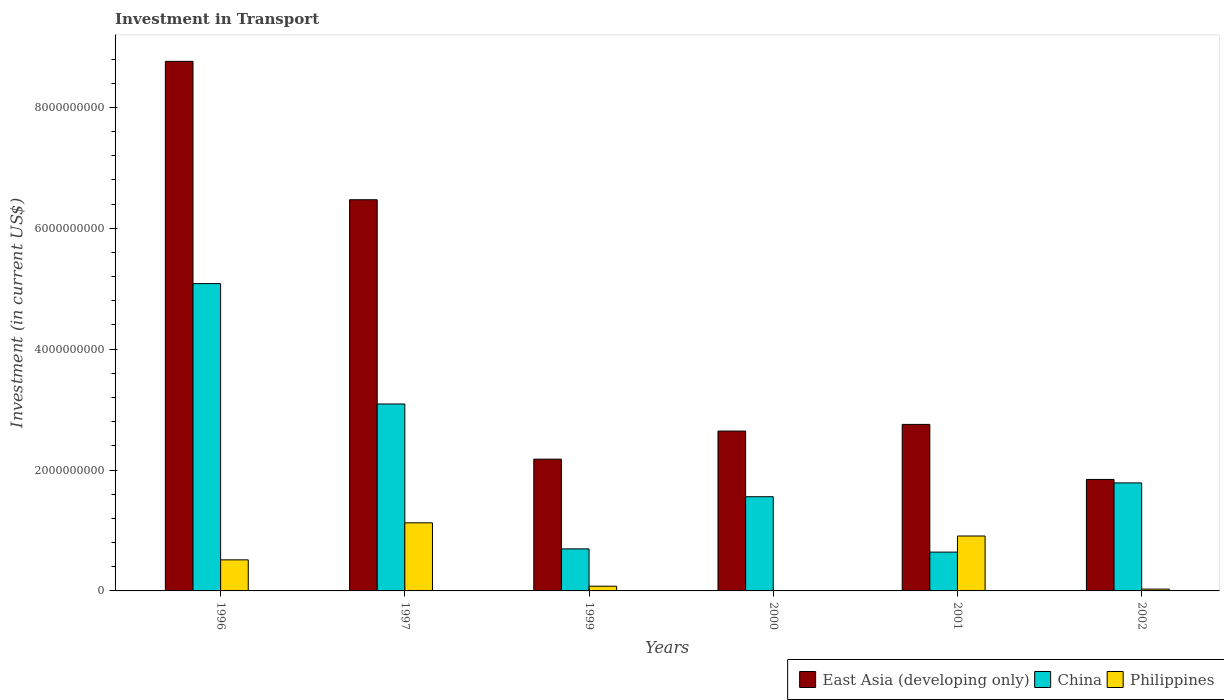Are the number of bars on each tick of the X-axis equal?
Offer a very short reply. Yes. How many bars are there on the 5th tick from the right?
Your answer should be very brief. 3. In how many cases, is the number of bars for a given year not equal to the number of legend labels?
Your answer should be very brief. 0. What is the amount invested in transport in Philippines in 2002?
Provide a short and direct response. 3.01e+07. Across all years, what is the maximum amount invested in transport in Philippines?
Keep it short and to the point. 1.13e+09. Across all years, what is the minimum amount invested in transport in China?
Provide a succinct answer. 6.42e+08. What is the total amount invested in transport in East Asia (developing only) in the graph?
Ensure brevity in your answer.  2.47e+1. What is the difference between the amount invested in transport in China in 1996 and that in 1997?
Ensure brevity in your answer.  1.99e+09. What is the difference between the amount invested in transport in Philippines in 1997 and the amount invested in transport in East Asia (developing only) in 2001?
Your answer should be compact. -1.63e+09. What is the average amount invested in transport in China per year?
Keep it short and to the point. 2.14e+09. In the year 1996, what is the difference between the amount invested in transport in China and amount invested in transport in Philippines?
Your response must be concise. 4.57e+09. What is the ratio of the amount invested in transport in Philippines in 1996 to that in 1997?
Provide a short and direct response. 0.46. Is the amount invested in transport in China in 1996 less than that in 1999?
Your answer should be compact. No. Is the difference between the amount invested in transport in China in 1997 and 2001 greater than the difference between the amount invested in transport in Philippines in 1997 and 2001?
Your answer should be compact. Yes. What is the difference between the highest and the second highest amount invested in transport in China?
Make the answer very short. 1.99e+09. What is the difference between the highest and the lowest amount invested in transport in China?
Your answer should be very brief. 4.44e+09. Is the sum of the amount invested in transport in China in 1996 and 2001 greater than the maximum amount invested in transport in Philippines across all years?
Offer a terse response. Yes. What does the 1st bar from the left in 2001 represents?
Your answer should be very brief. East Asia (developing only). Is it the case that in every year, the sum of the amount invested in transport in Philippines and amount invested in transport in China is greater than the amount invested in transport in East Asia (developing only)?
Ensure brevity in your answer.  No. How many years are there in the graph?
Keep it short and to the point. 6. What is the difference between two consecutive major ticks on the Y-axis?
Ensure brevity in your answer.  2.00e+09. How are the legend labels stacked?
Ensure brevity in your answer.  Horizontal. What is the title of the graph?
Your answer should be very brief. Investment in Transport. What is the label or title of the X-axis?
Offer a very short reply. Years. What is the label or title of the Y-axis?
Your answer should be very brief. Investment (in current US$). What is the Investment (in current US$) in East Asia (developing only) in 1996?
Your answer should be very brief. 8.76e+09. What is the Investment (in current US$) in China in 1996?
Keep it short and to the point. 5.08e+09. What is the Investment (in current US$) in Philippines in 1996?
Ensure brevity in your answer.  5.14e+08. What is the Investment (in current US$) of East Asia (developing only) in 1997?
Give a very brief answer. 6.47e+09. What is the Investment (in current US$) of China in 1997?
Provide a succinct answer. 3.09e+09. What is the Investment (in current US$) in Philippines in 1997?
Provide a succinct answer. 1.13e+09. What is the Investment (in current US$) in East Asia (developing only) in 1999?
Your answer should be compact. 2.18e+09. What is the Investment (in current US$) of China in 1999?
Your response must be concise. 6.96e+08. What is the Investment (in current US$) of Philippines in 1999?
Your response must be concise. 7.83e+07. What is the Investment (in current US$) of East Asia (developing only) in 2000?
Provide a succinct answer. 2.64e+09. What is the Investment (in current US$) of China in 2000?
Make the answer very short. 1.56e+09. What is the Investment (in current US$) in Philippines in 2000?
Offer a very short reply. 4.90e+06. What is the Investment (in current US$) of East Asia (developing only) in 2001?
Offer a terse response. 2.76e+09. What is the Investment (in current US$) of China in 2001?
Ensure brevity in your answer.  6.42e+08. What is the Investment (in current US$) of Philippines in 2001?
Keep it short and to the point. 9.08e+08. What is the Investment (in current US$) of East Asia (developing only) in 2002?
Your answer should be compact. 1.84e+09. What is the Investment (in current US$) of China in 2002?
Make the answer very short. 1.79e+09. What is the Investment (in current US$) in Philippines in 2002?
Keep it short and to the point. 3.01e+07. Across all years, what is the maximum Investment (in current US$) in East Asia (developing only)?
Keep it short and to the point. 8.76e+09. Across all years, what is the maximum Investment (in current US$) of China?
Your response must be concise. 5.08e+09. Across all years, what is the maximum Investment (in current US$) of Philippines?
Your answer should be compact. 1.13e+09. Across all years, what is the minimum Investment (in current US$) in East Asia (developing only)?
Your response must be concise. 1.84e+09. Across all years, what is the minimum Investment (in current US$) in China?
Provide a short and direct response. 6.42e+08. Across all years, what is the minimum Investment (in current US$) in Philippines?
Keep it short and to the point. 4.90e+06. What is the total Investment (in current US$) in East Asia (developing only) in the graph?
Your answer should be compact. 2.47e+1. What is the total Investment (in current US$) of China in the graph?
Offer a very short reply. 1.29e+1. What is the total Investment (in current US$) of Philippines in the graph?
Offer a terse response. 2.66e+09. What is the difference between the Investment (in current US$) in East Asia (developing only) in 1996 and that in 1997?
Offer a very short reply. 2.29e+09. What is the difference between the Investment (in current US$) in China in 1996 and that in 1997?
Your response must be concise. 1.99e+09. What is the difference between the Investment (in current US$) in Philippines in 1996 and that in 1997?
Your answer should be compact. -6.13e+08. What is the difference between the Investment (in current US$) of East Asia (developing only) in 1996 and that in 1999?
Your response must be concise. 6.58e+09. What is the difference between the Investment (in current US$) of China in 1996 and that in 1999?
Give a very brief answer. 4.39e+09. What is the difference between the Investment (in current US$) of Philippines in 1996 and that in 1999?
Provide a short and direct response. 4.36e+08. What is the difference between the Investment (in current US$) of East Asia (developing only) in 1996 and that in 2000?
Your answer should be compact. 6.12e+09. What is the difference between the Investment (in current US$) of China in 1996 and that in 2000?
Make the answer very short. 3.53e+09. What is the difference between the Investment (in current US$) in Philippines in 1996 and that in 2000?
Keep it short and to the point. 5.09e+08. What is the difference between the Investment (in current US$) in East Asia (developing only) in 1996 and that in 2001?
Your answer should be very brief. 6.01e+09. What is the difference between the Investment (in current US$) of China in 1996 and that in 2001?
Your response must be concise. 4.44e+09. What is the difference between the Investment (in current US$) of Philippines in 1996 and that in 2001?
Your answer should be very brief. -3.94e+08. What is the difference between the Investment (in current US$) in East Asia (developing only) in 1996 and that in 2002?
Keep it short and to the point. 6.92e+09. What is the difference between the Investment (in current US$) in China in 1996 and that in 2002?
Keep it short and to the point. 3.30e+09. What is the difference between the Investment (in current US$) in Philippines in 1996 and that in 2002?
Offer a terse response. 4.84e+08. What is the difference between the Investment (in current US$) in East Asia (developing only) in 1997 and that in 1999?
Offer a very short reply. 4.29e+09. What is the difference between the Investment (in current US$) in China in 1997 and that in 1999?
Offer a very short reply. 2.40e+09. What is the difference between the Investment (in current US$) in Philippines in 1997 and that in 1999?
Your response must be concise. 1.05e+09. What is the difference between the Investment (in current US$) in East Asia (developing only) in 1997 and that in 2000?
Offer a terse response. 3.83e+09. What is the difference between the Investment (in current US$) of China in 1997 and that in 2000?
Provide a succinct answer. 1.53e+09. What is the difference between the Investment (in current US$) of Philippines in 1997 and that in 2000?
Provide a succinct answer. 1.12e+09. What is the difference between the Investment (in current US$) of East Asia (developing only) in 1997 and that in 2001?
Make the answer very short. 3.72e+09. What is the difference between the Investment (in current US$) in China in 1997 and that in 2001?
Your response must be concise. 2.45e+09. What is the difference between the Investment (in current US$) of Philippines in 1997 and that in 2001?
Your response must be concise. 2.18e+08. What is the difference between the Investment (in current US$) in East Asia (developing only) in 1997 and that in 2002?
Provide a short and direct response. 4.63e+09. What is the difference between the Investment (in current US$) in China in 1997 and that in 2002?
Your answer should be very brief. 1.31e+09. What is the difference between the Investment (in current US$) in Philippines in 1997 and that in 2002?
Make the answer very short. 1.10e+09. What is the difference between the Investment (in current US$) in East Asia (developing only) in 1999 and that in 2000?
Provide a short and direct response. -4.65e+08. What is the difference between the Investment (in current US$) in China in 1999 and that in 2000?
Your answer should be very brief. -8.63e+08. What is the difference between the Investment (in current US$) of Philippines in 1999 and that in 2000?
Your answer should be compact. 7.34e+07. What is the difference between the Investment (in current US$) of East Asia (developing only) in 1999 and that in 2001?
Your answer should be very brief. -5.75e+08. What is the difference between the Investment (in current US$) of China in 1999 and that in 2001?
Make the answer very short. 5.33e+07. What is the difference between the Investment (in current US$) of Philippines in 1999 and that in 2001?
Your answer should be compact. -8.30e+08. What is the difference between the Investment (in current US$) of East Asia (developing only) in 1999 and that in 2002?
Provide a short and direct response. 3.35e+08. What is the difference between the Investment (in current US$) of China in 1999 and that in 2002?
Your answer should be very brief. -1.09e+09. What is the difference between the Investment (in current US$) in Philippines in 1999 and that in 2002?
Offer a terse response. 4.82e+07. What is the difference between the Investment (in current US$) of East Asia (developing only) in 2000 and that in 2001?
Make the answer very short. -1.10e+08. What is the difference between the Investment (in current US$) of China in 2000 and that in 2001?
Keep it short and to the point. 9.16e+08. What is the difference between the Investment (in current US$) in Philippines in 2000 and that in 2001?
Provide a succinct answer. -9.04e+08. What is the difference between the Investment (in current US$) in East Asia (developing only) in 2000 and that in 2002?
Provide a short and direct response. 8.00e+08. What is the difference between the Investment (in current US$) of China in 2000 and that in 2002?
Your response must be concise. -2.29e+08. What is the difference between the Investment (in current US$) of Philippines in 2000 and that in 2002?
Give a very brief answer. -2.52e+07. What is the difference between the Investment (in current US$) in East Asia (developing only) in 2001 and that in 2002?
Provide a succinct answer. 9.11e+08. What is the difference between the Investment (in current US$) of China in 2001 and that in 2002?
Offer a very short reply. -1.14e+09. What is the difference between the Investment (in current US$) of Philippines in 2001 and that in 2002?
Give a very brief answer. 8.78e+08. What is the difference between the Investment (in current US$) of East Asia (developing only) in 1996 and the Investment (in current US$) of China in 1997?
Your answer should be compact. 5.67e+09. What is the difference between the Investment (in current US$) of East Asia (developing only) in 1996 and the Investment (in current US$) of Philippines in 1997?
Your answer should be very brief. 7.63e+09. What is the difference between the Investment (in current US$) in China in 1996 and the Investment (in current US$) in Philippines in 1997?
Your answer should be compact. 3.96e+09. What is the difference between the Investment (in current US$) in East Asia (developing only) in 1996 and the Investment (in current US$) in China in 1999?
Provide a short and direct response. 8.07e+09. What is the difference between the Investment (in current US$) in East Asia (developing only) in 1996 and the Investment (in current US$) in Philippines in 1999?
Ensure brevity in your answer.  8.68e+09. What is the difference between the Investment (in current US$) of China in 1996 and the Investment (in current US$) of Philippines in 1999?
Offer a very short reply. 5.01e+09. What is the difference between the Investment (in current US$) in East Asia (developing only) in 1996 and the Investment (in current US$) in China in 2000?
Provide a short and direct response. 7.20e+09. What is the difference between the Investment (in current US$) of East Asia (developing only) in 1996 and the Investment (in current US$) of Philippines in 2000?
Your answer should be compact. 8.76e+09. What is the difference between the Investment (in current US$) in China in 1996 and the Investment (in current US$) in Philippines in 2000?
Your answer should be compact. 5.08e+09. What is the difference between the Investment (in current US$) of East Asia (developing only) in 1996 and the Investment (in current US$) of China in 2001?
Your answer should be compact. 8.12e+09. What is the difference between the Investment (in current US$) in East Asia (developing only) in 1996 and the Investment (in current US$) in Philippines in 2001?
Your response must be concise. 7.85e+09. What is the difference between the Investment (in current US$) in China in 1996 and the Investment (in current US$) in Philippines in 2001?
Provide a succinct answer. 4.18e+09. What is the difference between the Investment (in current US$) in East Asia (developing only) in 1996 and the Investment (in current US$) in China in 2002?
Offer a terse response. 6.97e+09. What is the difference between the Investment (in current US$) of East Asia (developing only) in 1996 and the Investment (in current US$) of Philippines in 2002?
Ensure brevity in your answer.  8.73e+09. What is the difference between the Investment (in current US$) of China in 1996 and the Investment (in current US$) of Philippines in 2002?
Your answer should be compact. 5.05e+09. What is the difference between the Investment (in current US$) of East Asia (developing only) in 1997 and the Investment (in current US$) of China in 1999?
Give a very brief answer. 5.78e+09. What is the difference between the Investment (in current US$) of East Asia (developing only) in 1997 and the Investment (in current US$) of Philippines in 1999?
Keep it short and to the point. 6.39e+09. What is the difference between the Investment (in current US$) of China in 1997 and the Investment (in current US$) of Philippines in 1999?
Make the answer very short. 3.01e+09. What is the difference between the Investment (in current US$) of East Asia (developing only) in 1997 and the Investment (in current US$) of China in 2000?
Make the answer very short. 4.91e+09. What is the difference between the Investment (in current US$) of East Asia (developing only) in 1997 and the Investment (in current US$) of Philippines in 2000?
Give a very brief answer. 6.47e+09. What is the difference between the Investment (in current US$) of China in 1997 and the Investment (in current US$) of Philippines in 2000?
Your answer should be compact. 3.09e+09. What is the difference between the Investment (in current US$) of East Asia (developing only) in 1997 and the Investment (in current US$) of China in 2001?
Keep it short and to the point. 5.83e+09. What is the difference between the Investment (in current US$) in East Asia (developing only) in 1997 and the Investment (in current US$) in Philippines in 2001?
Provide a succinct answer. 5.56e+09. What is the difference between the Investment (in current US$) of China in 1997 and the Investment (in current US$) of Philippines in 2001?
Keep it short and to the point. 2.18e+09. What is the difference between the Investment (in current US$) in East Asia (developing only) in 1997 and the Investment (in current US$) in China in 2002?
Provide a short and direct response. 4.68e+09. What is the difference between the Investment (in current US$) in East Asia (developing only) in 1997 and the Investment (in current US$) in Philippines in 2002?
Give a very brief answer. 6.44e+09. What is the difference between the Investment (in current US$) of China in 1997 and the Investment (in current US$) of Philippines in 2002?
Offer a very short reply. 3.06e+09. What is the difference between the Investment (in current US$) in East Asia (developing only) in 1999 and the Investment (in current US$) in China in 2000?
Provide a short and direct response. 6.21e+08. What is the difference between the Investment (in current US$) in East Asia (developing only) in 1999 and the Investment (in current US$) in Philippines in 2000?
Make the answer very short. 2.17e+09. What is the difference between the Investment (in current US$) of China in 1999 and the Investment (in current US$) of Philippines in 2000?
Ensure brevity in your answer.  6.91e+08. What is the difference between the Investment (in current US$) of East Asia (developing only) in 1999 and the Investment (in current US$) of China in 2001?
Offer a very short reply. 1.54e+09. What is the difference between the Investment (in current US$) of East Asia (developing only) in 1999 and the Investment (in current US$) of Philippines in 2001?
Your answer should be compact. 1.27e+09. What is the difference between the Investment (in current US$) in China in 1999 and the Investment (in current US$) in Philippines in 2001?
Keep it short and to the point. -2.13e+08. What is the difference between the Investment (in current US$) of East Asia (developing only) in 1999 and the Investment (in current US$) of China in 2002?
Ensure brevity in your answer.  3.93e+08. What is the difference between the Investment (in current US$) of East Asia (developing only) in 1999 and the Investment (in current US$) of Philippines in 2002?
Ensure brevity in your answer.  2.15e+09. What is the difference between the Investment (in current US$) in China in 1999 and the Investment (in current US$) in Philippines in 2002?
Your answer should be compact. 6.65e+08. What is the difference between the Investment (in current US$) of East Asia (developing only) in 2000 and the Investment (in current US$) of China in 2001?
Your answer should be very brief. 2.00e+09. What is the difference between the Investment (in current US$) of East Asia (developing only) in 2000 and the Investment (in current US$) of Philippines in 2001?
Provide a short and direct response. 1.74e+09. What is the difference between the Investment (in current US$) of China in 2000 and the Investment (in current US$) of Philippines in 2001?
Ensure brevity in your answer.  6.50e+08. What is the difference between the Investment (in current US$) in East Asia (developing only) in 2000 and the Investment (in current US$) in China in 2002?
Your response must be concise. 8.57e+08. What is the difference between the Investment (in current US$) in East Asia (developing only) in 2000 and the Investment (in current US$) in Philippines in 2002?
Your answer should be very brief. 2.61e+09. What is the difference between the Investment (in current US$) in China in 2000 and the Investment (in current US$) in Philippines in 2002?
Offer a terse response. 1.53e+09. What is the difference between the Investment (in current US$) in East Asia (developing only) in 2001 and the Investment (in current US$) in China in 2002?
Your response must be concise. 9.68e+08. What is the difference between the Investment (in current US$) of East Asia (developing only) in 2001 and the Investment (in current US$) of Philippines in 2002?
Keep it short and to the point. 2.72e+09. What is the difference between the Investment (in current US$) of China in 2001 and the Investment (in current US$) of Philippines in 2002?
Keep it short and to the point. 6.12e+08. What is the average Investment (in current US$) in East Asia (developing only) per year?
Make the answer very short. 4.11e+09. What is the average Investment (in current US$) in China per year?
Offer a terse response. 2.14e+09. What is the average Investment (in current US$) in Philippines per year?
Your response must be concise. 4.44e+08. In the year 1996, what is the difference between the Investment (in current US$) of East Asia (developing only) and Investment (in current US$) of China?
Provide a short and direct response. 3.68e+09. In the year 1996, what is the difference between the Investment (in current US$) of East Asia (developing only) and Investment (in current US$) of Philippines?
Give a very brief answer. 8.25e+09. In the year 1996, what is the difference between the Investment (in current US$) in China and Investment (in current US$) in Philippines?
Your response must be concise. 4.57e+09. In the year 1997, what is the difference between the Investment (in current US$) of East Asia (developing only) and Investment (in current US$) of China?
Ensure brevity in your answer.  3.38e+09. In the year 1997, what is the difference between the Investment (in current US$) of East Asia (developing only) and Investment (in current US$) of Philippines?
Ensure brevity in your answer.  5.35e+09. In the year 1997, what is the difference between the Investment (in current US$) in China and Investment (in current US$) in Philippines?
Offer a very short reply. 1.97e+09. In the year 1999, what is the difference between the Investment (in current US$) of East Asia (developing only) and Investment (in current US$) of China?
Your answer should be compact. 1.48e+09. In the year 1999, what is the difference between the Investment (in current US$) of East Asia (developing only) and Investment (in current US$) of Philippines?
Give a very brief answer. 2.10e+09. In the year 1999, what is the difference between the Investment (in current US$) of China and Investment (in current US$) of Philippines?
Give a very brief answer. 6.17e+08. In the year 2000, what is the difference between the Investment (in current US$) in East Asia (developing only) and Investment (in current US$) in China?
Ensure brevity in your answer.  1.09e+09. In the year 2000, what is the difference between the Investment (in current US$) of East Asia (developing only) and Investment (in current US$) of Philippines?
Offer a very short reply. 2.64e+09. In the year 2000, what is the difference between the Investment (in current US$) in China and Investment (in current US$) in Philippines?
Your answer should be very brief. 1.55e+09. In the year 2001, what is the difference between the Investment (in current US$) of East Asia (developing only) and Investment (in current US$) of China?
Keep it short and to the point. 2.11e+09. In the year 2001, what is the difference between the Investment (in current US$) of East Asia (developing only) and Investment (in current US$) of Philippines?
Provide a short and direct response. 1.85e+09. In the year 2001, what is the difference between the Investment (in current US$) in China and Investment (in current US$) in Philippines?
Keep it short and to the point. -2.66e+08. In the year 2002, what is the difference between the Investment (in current US$) in East Asia (developing only) and Investment (in current US$) in China?
Keep it short and to the point. 5.73e+07. In the year 2002, what is the difference between the Investment (in current US$) in East Asia (developing only) and Investment (in current US$) in Philippines?
Your response must be concise. 1.81e+09. In the year 2002, what is the difference between the Investment (in current US$) of China and Investment (in current US$) of Philippines?
Your response must be concise. 1.76e+09. What is the ratio of the Investment (in current US$) of East Asia (developing only) in 1996 to that in 1997?
Your answer should be very brief. 1.35. What is the ratio of the Investment (in current US$) of China in 1996 to that in 1997?
Your response must be concise. 1.64. What is the ratio of the Investment (in current US$) in Philippines in 1996 to that in 1997?
Your answer should be very brief. 0.46. What is the ratio of the Investment (in current US$) of East Asia (developing only) in 1996 to that in 1999?
Provide a short and direct response. 4.02. What is the ratio of the Investment (in current US$) in China in 1996 to that in 1999?
Offer a terse response. 7.31. What is the ratio of the Investment (in current US$) in Philippines in 1996 to that in 1999?
Provide a short and direct response. 6.56. What is the ratio of the Investment (in current US$) in East Asia (developing only) in 1996 to that in 2000?
Ensure brevity in your answer.  3.31. What is the ratio of the Investment (in current US$) of China in 1996 to that in 2000?
Offer a very short reply. 3.26. What is the ratio of the Investment (in current US$) in Philippines in 1996 to that in 2000?
Offer a terse response. 104.9. What is the ratio of the Investment (in current US$) of East Asia (developing only) in 1996 to that in 2001?
Offer a terse response. 3.18. What is the ratio of the Investment (in current US$) in China in 1996 to that in 2001?
Your response must be concise. 7.92. What is the ratio of the Investment (in current US$) in Philippines in 1996 to that in 2001?
Offer a very short reply. 0.57. What is the ratio of the Investment (in current US$) in East Asia (developing only) in 1996 to that in 2002?
Your answer should be very brief. 4.75. What is the ratio of the Investment (in current US$) in China in 1996 to that in 2002?
Ensure brevity in your answer.  2.85. What is the ratio of the Investment (in current US$) of Philippines in 1996 to that in 2002?
Your response must be concise. 17.08. What is the ratio of the Investment (in current US$) of East Asia (developing only) in 1997 to that in 1999?
Provide a succinct answer. 2.97. What is the ratio of the Investment (in current US$) in China in 1997 to that in 1999?
Ensure brevity in your answer.  4.45. What is the ratio of the Investment (in current US$) of Philippines in 1997 to that in 1999?
Ensure brevity in your answer.  14.39. What is the ratio of the Investment (in current US$) in East Asia (developing only) in 1997 to that in 2000?
Your response must be concise. 2.45. What is the ratio of the Investment (in current US$) of China in 1997 to that in 2000?
Make the answer very short. 1.98. What is the ratio of the Investment (in current US$) in Philippines in 1997 to that in 2000?
Your response must be concise. 229.94. What is the ratio of the Investment (in current US$) in East Asia (developing only) in 1997 to that in 2001?
Your answer should be very brief. 2.35. What is the ratio of the Investment (in current US$) in China in 1997 to that in 2001?
Give a very brief answer. 4.82. What is the ratio of the Investment (in current US$) in Philippines in 1997 to that in 2001?
Offer a terse response. 1.24. What is the ratio of the Investment (in current US$) in East Asia (developing only) in 1997 to that in 2002?
Your answer should be compact. 3.51. What is the ratio of the Investment (in current US$) of China in 1997 to that in 2002?
Make the answer very short. 1.73. What is the ratio of the Investment (in current US$) in Philippines in 1997 to that in 2002?
Offer a very short reply. 37.43. What is the ratio of the Investment (in current US$) in East Asia (developing only) in 1999 to that in 2000?
Ensure brevity in your answer.  0.82. What is the ratio of the Investment (in current US$) in China in 1999 to that in 2000?
Keep it short and to the point. 0.45. What is the ratio of the Investment (in current US$) in Philippines in 1999 to that in 2000?
Provide a succinct answer. 15.98. What is the ratio of the Investment (in current US$) in East Asia (developing only) in 1999 to that in 2001?
Your answer should be compact. 0.79. What is the ratio of the Investment (in current US$) in China in 1999 to that in 2001?
Offer a very short reply. 1.08. What is the ratio of the Investment (in current US$) in Philippines in 1999 to that in 2001?
Your response must be concise. 0.09. What is the ratio of the Investment (in current US$) in East Asia (developing only) in 1999 to that in 2002?
Offer a terse response. 1.18. What is the ratio of the Investment (in current US$) of China in 1999 to that in 2002?
Offer a very short reply. 0.39. What is the ratio of the Investment (in current US$) of Philippines in 1999 to that in 2002?
Provide a succinct answer. 2.6. What is the ratio of the Investment (in current US$) in East Asia (developing only) in 2000 to that in 2001?
Your answer should be compact. 0.96. What is the ratio of the Investment (in current US$) of China in 2000 to that in 2001?
Give a very brief answer. 2.43. What is the ratio of the Investment (in current US$) of Philippines in 2000 to that in 2001?
Provide a short and direct response. 0.01. What is the ratio of the Investment (in current US$) of East Asia (developing only) in 2000 to that in 2002?
Give a very brief answer. 1.43. What is the ratio of the Investment (in current US$) of China in 2000 to that in 2002?
Ensure brevity in your answer.  0.87. What is the ratio of the Investment (in current US$) of Philippines in 2000 to that in 2002?
Your answer should be very brief. 0.16. What is the ratio of the Investment (in current US$) in East Asia (developing only) in 2001 to that in 2002?
Offer a terse response. 1.49. What is the ratio of the Investment (in current US$) of China in 2001 to that in 2002?
Provide a succinct answer. 0.36. What is the ratio of the Investment (in current US$) in Philippines in 2001 to that in 2002?
Provide a succinct answer. 30.18. What is the difference between the highest and the second highest Investment (in current US$) of East Asia (developing only)?
Your answer should be compact. 2.29e+09. What is the difference between the highest and the second highest Investment (in current US$) of China?
Give a very brief answer. 1.99e+09. What is the difference between the highest and the second highest Investment (in current US$) in Philippines?
Ensure brevity in your answer.  2.18e+08. What is the difference between the highest and the lowest Investment (in current US$) of East Asia (developing only)?
Offer a terse response. 6.92e+09. What is the difference between the highest and the lowest Investment (in current US$) in China?
Provide a short and direct response. 4.44e+09. What is the difference between the highest and the lowest Investment (in current US$) of Philippines?
Give a very brief answer. 1.12e+09. 